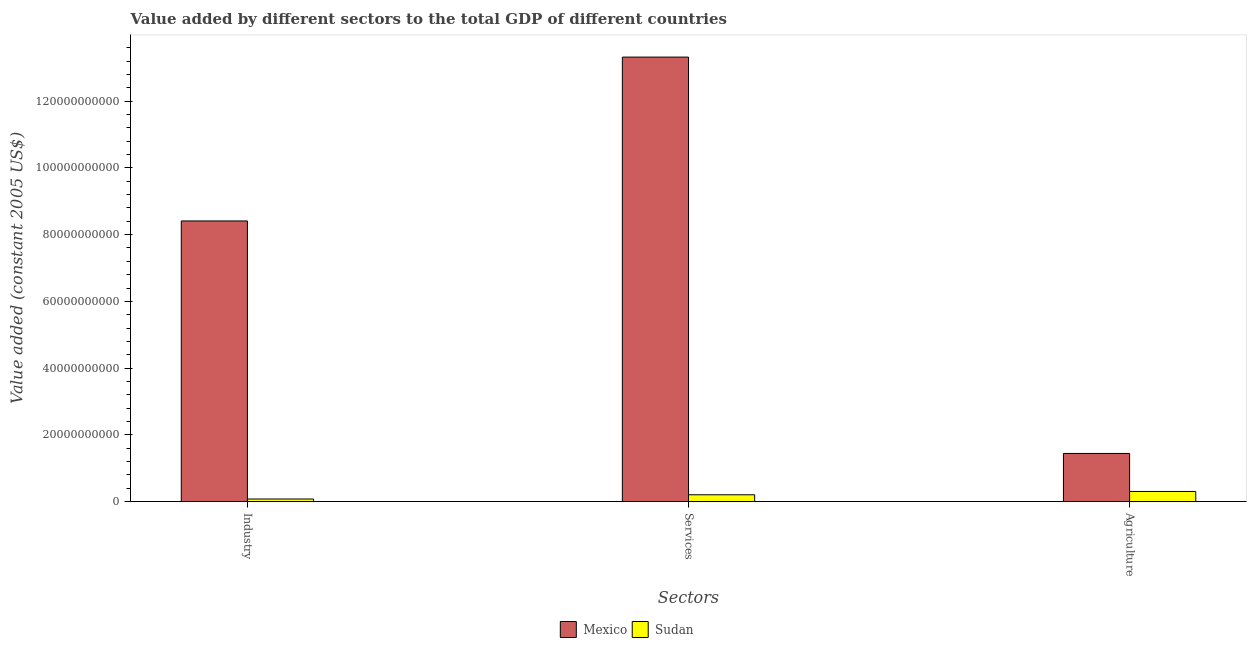How many different coloured bars are there?
Provide a short and direct response. 2. Are the number of bars per tick equal to the number of legend labels?
Offer a very short reply. Yes. Are the number of bars on each tick of the X-axis equal?
Your response must be concise. Yes. What is the label of the 1st group of bars from the left?
Ensure brevity in your answer.  Industry. What is the value added by agricultural sector in Sudan?
Offer a very short reply. 3.03e+09. Across all countries, what is the maximum value added by agricultural sector?
Ensure brevity in your answer.  1.44e+1. Across all countries, what is the minimum value added by industrial sector?
Offer a very short reply. 7.61e+08. In which country was the value added by industrial sector minimum?
Make the answer very short. Sudan. What is the total value added by services in the graph?
Ensure brevity in your answer.  1.35e+11. What is the difference between the value added by services in Sudan and that in Mexico?
Your answer should be compact. -1.31e+11. What is the difference between the value added by services in Mexico and the value added by agricultural sector in Sudan?
Provide a succinct answer. 1.30e+11. What is the average value added by agricultural sector per country?
Ensure brevity in your answer.  8.73e+09. What is the difference between the value added by industrial sector and value added by services in Sudan?
Offer a terse response. -1.27e+09. In how many countries, is the value added by agricultural sector greater than 92000000000 US$?
Your response must be concise. 0. What is the ratio of the value added by industrial sector in Mexico to that in Sudan?
Provide a succinct answer. 110.46. Is the value added by industrial sector in Mexico less than that in Sudan?
Make the answer very short. No. What is the difference between the highest and the second highest value added by agricultural sector?
Your response must be concise. 1.14e+1. What is the difference between the highest and the lowest value added by services?
Offer a terse response. 1.31e+11. In how many countries, is the value added by industrial sector greater than the average value added by industrial sector taken over all countries?
Your answer should be compact. 1. What does the 2nd bar from the left in Agriculture represents?
Keep it short and to the point. Sudan. Is it the case that in every country, the sum of the value added by industrial sector and value added by services is greater than the value added by agricultural sector?
Your response must be concise. No. Does the graph contain any zero values?
Keep it short and to the point. No. Does the graph contain grids?
Make the answer very short. No. How are the legend labels stacked?
Your answer should be very brief. Horizontal. What is the title of the graph?
Offer a terse response. Value added by different sectors to the total GDP of different countries. Does "Mexico" appear as one of the legend labels in the graph?
Provide a short and direct response. Yes. What is the label or title of the X-axis?
Give a very brief answer. Sectors. What is the label or title of the Y-axis?
Keep it short and to the point. Value added (constant 2005 US$). What is the Value added (constant 2005 US$) in Mexico in Industry?
Provide a short and direct response. 8.41e+1. What is the Value added (constant 2005 US$) of Sudan in Industry?
Provide a short and direct response. 7.61e+08. What is the Value added (constant 2005 US$) of Mexico in Services?
Ensure brevity in your answer.  1.33e+11. What is the Value added (constant 2005 US$) in Sudan in Services?
Offer a terse response. 2.04e+09. What is the Value added (constant 2005 US$) in Mexico in Agriculture?
Ensure brevity in your answer.  1.44e+1. What is the Value added (constant 2005 US$) of Sudan in Agriculture?
Give a very brief answer. 3.03e+09. Across all Sectors, what is the maximum Value added (constant 2005 US$) in Mexico?
Give a very brief answer. 1.33e+11. Across all Sectors, what is the maximum Value added (constant 2005 US$) in Sudan?
Offer a very short reply. 3.03e+09. Across all Sectors, what is the minimum Value added (constant 2005 US$) of Mexico?
Your response must be concise. 1.44e+1. Across all Sectors, what is the minimum Value added (constant 2005 US$) of Sudan?
Provide a short and direct response. 7.61e+08. What is the total Value added (constant 2005 US$) of Mexico in the graph?
Your response must be concise. 2.32e+11. What is the total Value added (constant 2005 US$) in Sudan in the graph?
Make the answer very short. 5.83e+09. What is the difference between the Value added (constant 2005 US$) in Mexico in Industry and that in Services?
Provide a short and direct response. -4.91e+1. What is the difference between the Value added (constant 2005 US$) of Sudan in Industry and that in Services?
Provide a succinct answer. -1.27e+09. What is the difference between the Value added (constant 2005 US$) of Mexico in Industry and that in Agriculture?
Offer a terse response. 6.97e+1. What is the difference between the Value added (constant 2005 US$) of Sudan in Industry and that in Agriculture?
Keep it short and to the point. -2.27e+09. What is the difference between the Value added (constant 2005 US$) of Mexico in Services and that in Agriculture?
Your answer should be very brief. 1.19e+11. What is the difference between the Value added (constant 2005 US$) of Sudan in Services and that in Agriculture?
Give a very brief answer. -9.93e+08. What is the difference between the Value added (constant 2005 US$) of Mexico in Industry and the Value added (constant 2005 US$) of Sudan in Services?
Ensure brevity in your answer.  8.21e+1. What is the difference between the Value added (constant 2005 US$) of Mexico in Industry and the Value added (constant 2005 US$) of Sudan in Agriculture?
Provide a short and direct response. 8.11e+1. What is the difference between the Value added (constant 2005 US$) of Mexico in Services and the Value added (constant 2005 US$) of Sudan in Agriculture?
Provide a short and direct response. 1.30e+11. What is the average Value added (constant 2005 US$) of Mexico per Sectors?
Your response must be concise. 7.72e+1. What is the average Value added (constant 2005 US$) of Sudan per Sectors?
Provide a short and direct response. 1.94e+09. What is the difference between the Value added (constant 2005 US$) of Mexico and Value added (constant 2005 US$) of Sudan in Industry?
Your answer should be very brief. 8.33e+1. What is the difference between the Value added (constant 2005 US$) of Mexico and Value added (constant 2005 US$) of Sudan in Services?
Make the answer very short. 1.31e+11. What is the difference between the Value added (constant 2005 US$) of Mexico and Value added (constant 2005 US$) of Sudan in Agriculture?
Provide a succinct answer. 1.14e+1. What is the ratio of the Value added (constant 2005 US$) of Mexico in Industry to that in Services?
Offer a terse response. 0.63. What is the ratio of the Value added (constant 2005 US$) in Sudan in Industry to that in Services?
Your response must be concise. 0.37. What is the ratio of the Value added (constant 2005 US$) of Mexico in Industry to that in Agriculture?
Keep it short and to the point. 5.83. What is the ratio of the Value added (constant 2005 US$) in Sudan in Industry to that in Agriculture?
Keep it short and to the point. 0.25. What is the ratio of the Value added (constant 2005 US$) of Mexico in Services to that in Agriculture?
Your answer should be compact. 9.24. What is the ratio of the Value added (constant 2005 US$) in Sudan in Services to that in Agriculture?
Provide a succinct answer. 0.67. What is the difference between the highest and the second highest Value added (constant 2005 US$) of Mexico?
Your answer should be very brief. 4.91e+1. What is the difference between the highest and the second highest Value added (constant 2005 US$) in Sudan?
Offer a very short reply. 9.93e+08. What is the difference between the highest and the lowest Value added (constant 2005 US$) of Mexico?
Provide a succinct answer. 1.19e+11. What is the difference between the highest and the lowest Value added (constant 2005 US$) in Sudan?
Provide a short and direct response. 2.27e+09. 